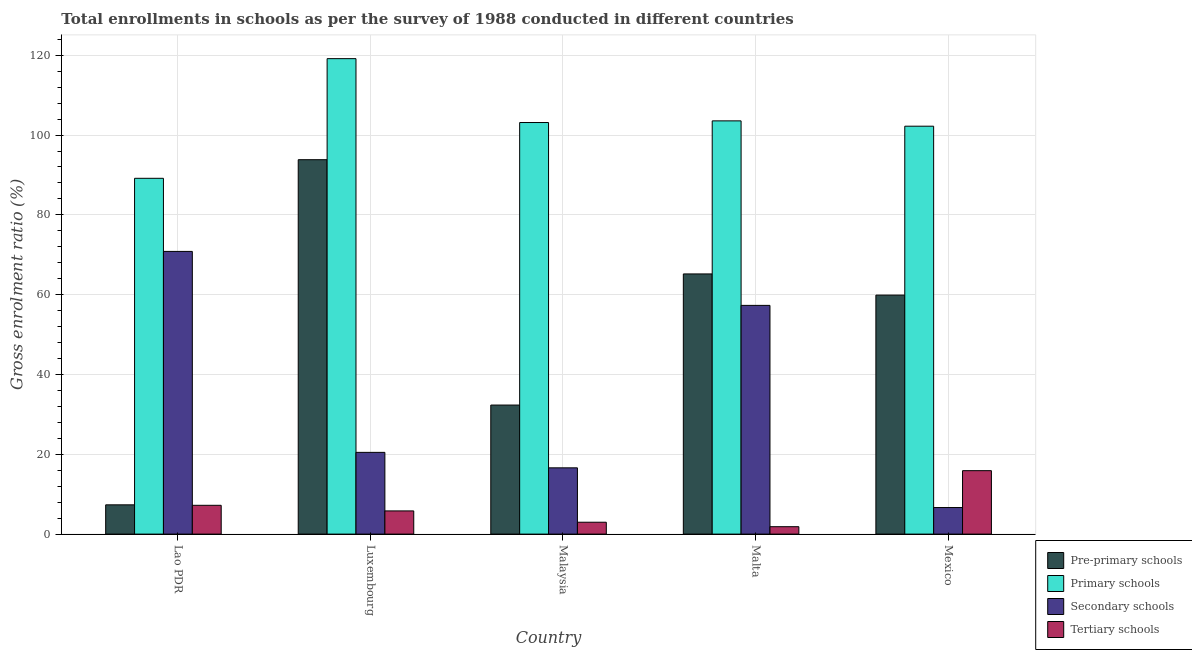How many groups of bars are there?
Provide a succinct answer. 5. What is the label of the 1st group of bars from the left?
Your response must be concise. Lao PDR. In how many cases, is the number of bars for a given country not equal to the number of legend labels?
Offer a very short reply. 0. What is the gross enrolment ratio in tertiary schools in Malta?
Offer a terse response. 1.86. Across all countries, what is the maximum gross enrolment ratio in tertiary schools?
Provide a succinct answer. 15.9. Across all countries, what is the minimum gross enrolment ratio in primary schools?
Ensure brevity in your answer.  89.17. In which country was the gross enrolment ratio in secondary schools maximum?
Your answer should be compact. Lao PDR. In which country was the gross enrolment ratio in primary schools minimum?
Keep it short and to the point. Lao PDR. What is the total gross enrolment ratio in pre-primary schools in the graph?
Keep it short and to the point. 258.6. What is the difference between the gross enrolment ratio in pre-primary schools in Luxembourg and that in Malta?
Give a very brief answer. 28.63. What is the difference between the gross enrolment ratio in secondary schools in Malaysia and the gross enrolment ratio in primary schools in Luxembourg?
Make the answer very short. -102.55. What is the average gross enrolment ratio in pre-primary schools per country?
Ensure brevity in your answer.  51.72. What is the difference between the gross enrolment ratio in tertiary schools and gross enrolment ratio in pre-primary schools in Lao PDR?
Give a very brief answer. -0.12. What is the ratio of the gross enrolment ratio in tertiary schools in Lao PDR to that in Malaysia?
Your answer should be compact. 2.42. Is the difference between the gross enrolment ratio in pre-primary schools in Luxembourg and Malta greater than the difference between the gross enrolment ratio in tertiary schools in Luxembourg and Malta?
Keep it short and to the point. Yes. What is the difference between the highest and the second highest gross enrolment ratio in pre-primary schools?
Offer a terse response. 28.63. What is the difference between the highest and the lowest gross enrolment ratio in pre-primary schools?
Provide a succinct answer. 86.49. In how many countries, is the gross enrolment ratio in secondary schools greater than the average gross enrolment ratio in secondary schools taken over all countries?
Ensure brevity in your answer.  2. What does the 2nd bar from the left in Mexico represents?
Your answer should be compact. Primary schools. What does the 1st bar from the right in Malaysia represents?
Provide a succinct answer. Tertiary schools. Is it the case that in every country, the sum of the gross enrolment ratio in pre-primary schools and gross enrolment ratio in primary schools is greater than the gross enrolment ratio in secondary schools?
Keep it short and to the point. Yes. Are the values on the major ticks of Y-axis written in scientific E-notation?
Your answer should be compact. No. Does the graph contain grids?
Provide a succinct answer. Yes. How many legend labels are there?
Offer a very short reply. 4. What is the title of the graph?
Provide a succinct answer. Total enrollments in schools as per the survey of 1988 conducted in different countries. What is the label or title of the X-axis?
Make the answer very short. Country. What is the label or title of the Y-axis?
Provide a short and direct response. Gross enrolment ratio (%). What is the Gross enrolment ratio (%) of Pre-primary schools in Lao PDR?
Ensure brevity in your answer.  7.33. What is the Gross enrolment ratio (%) in Primary schools in Lao PDR?
Your answer should be compact. 89.17. What is the Gross enrolment ratio (%) in Secondary schools in Lao PDR?
Provide a succinct answer. 70.84. What is the Gross enrolment ratio (%) in Tertiary schools in Lao PDR?
Your answer should be very brief. 7.22. What is the Gross enrolment ratio (%) of Pre-primary schools in Luxembourg?
Offer a terse response. 93.83. What is the Gross enrolment ratio (%) in Primary schools in Luxembourg?
Your answer should be compact. 119.15. What is the Gross enrolment ratio (%) in Secondary schools in Luxembourg?
Your answer should be compact. 20.48. What is the Gross enrolment ratio (%) of Tertiary schools in Luxembourg?
Provide a succinct answer. 5.81. What is the Gross enrolment ratio (%) of Pre-primary schools in Malaysia?
Your answer should be very brief. 32.34. What is the Gross enrolment ratio (%) of Primary schools in Malaysia?
Offer a very short reply. 103.14. What is the Gross enrolment ratio (%) in Secondary schools in Malaysia?
Ensure brevity in your answer.  16.61. What is the Gross enrolment ratio (%) of Tertiary schools in Malaysia?
Your answer should be compact. 2.98. What is the Gross enrolment ratio (%) of Pre-primary schools in Malta?
Your answer should be very brief. 65.2. What is the Gross enrolment ratio (%) of Primary schools in Malta?
Make the answer very short. 103.56. What is the Gross enrolment ratio (%) in Secondary schools in Malta?
Give a very brief answer. 57.32. What is the Gross enrolment ratio (%) of Tertiary schools in Malta?
Offer a terse response. 1.86. What is the Gross enrolment ratio (%) of Pre-primary schools in Mexico?
Your answer should be compact. 59.89. What is the Gross enrolment ratio (%) in Primary schools in Mexico?
Keep it short and to the point. 102.22. What is the Gross enrolment ratio (%) in Secondary schools in Mexico?
Provide a short and direct response. 6.66. What is the Gross enrolment ratio (%) of Tertiary schools in Mexico?
Keep it short and to the point. 15.9. Across all countries, what is the maximum Gross enrolment ratio (%) in Pre-primary schools?
Your answer should be very brief. 93.83. Across all countries, what is the maximum Gross enrolment ratio (%) of Primary schools?
Offer a very short reply. 119.15. Across all countries, what is the maximum Gross enrolment ratio (%) of Secondary schools?
Your answer should be very brief. 70.84. Across all countries, what is the maximum Gross enrolment ratio (%) in Tertiary schools?
Your answer should be very brief. 15.9. Across all countries, what is the minimum Gross enrolment ratio (%) of Pre-primary schools?
Your answer should be compact. 7.33. Across all countries, what is the minimum Gross enrolment ratio (%) of Primary schools?
Make the answer very short. 89.17. Across all countries, what is the minimum Gross enrolment ratio (%) of Secondary schools?
Provide a short and direct response. 6.66. Across all countries, what is the minimum Gross enrolment ratio (%) of Tertiary schools?
Keep it short and to the point. 1.86. What is the total Gross enrolment ratio (%) in Pre-primary schools in the graph?
Your answer should be compact. 258.6. What is the total Gross enrolment ratio (%) in Primary schools in the graph?
Your response must be concise. 517.24. What is the total Gross enrolment ratio (%) in Secondary schools in the graph?
Offer a very short reply. 171.91. What is the total Gross enrolment ratio (%) in Tertiary schools in the graph?
Provide a short and direct response. 33.76. What is the difference between the Gross enrolment ratio (%) of Pre-primary schools in Lao PDR and that in Luxembourg?
Ensure brevity in your answer.  -86.49. What is the difference between the Gross enrolment ratio (%) in Primary schools in Lao PDR and that in Luxembourg?
Keep it short and to the point. -29.99. What is the difference between the Gross enrolment ratio (%) of Secondary schools in Lao PDR and that in Luxembourg?
Offer a very short reply. 50.36. What is the difference between the Gross enrolment ratio (%) in Tertiary schools in Lao PDR and that in Luxembourg?
Offer a very short reply. 1.4. What is the difference between the Gross enrolment ratio (%) in Pre-primary schools in Lao PDR and that in Malaysia?
Make the answer very short. -25. What is the difference between the Gross enrolment ratio (%) of Primary schools in Lao PDR and that in Malaysia?
Your answer should be compact. -13.98. What is the difference between the Gross enrolment ratio (%) in Secondary schools in Lao PDR and that in Malaysia?
Offer a terse response. 54.24. What is the difference between the Gross enrolment ratio (%) in Tertiary schools in Lao PDR and that in Malaysia?
Give a very brief answer. 4.24. What is the difference between the Gross enrolment ratio (%) of Pre-primary schools in Lao PDR and that in Malta?
Ensure brevity in your answer.  -57.86. What is the difference between the Gross enrolment ratio (%) in Primary schools in Lao PDR and that in Malta?
Give a very brief answer. -14.39. What is the difference between the Gross enrolment ratio (%) in Secondary schools in Lao PDR and that in Malta?
Ensure brevity in your answer.  13.52. What is the difference between the Gross enrolment ratio (%) in Tertiary schools in Lao PDR and that in Malta?
Your response must be concise. 5.36. What is the difference between the Gross enrolment ratio (%) of Pre-primary schools in Lao PDR and that in Mexico?
Make the answer very short. -52.56. What is the difference between the Gross enrolment ratio (%) of Primary schools in Lao PDR and that in Mexico?
Your answer should be very brief. -13.06. What is the difference between the Gross enrolment ratio (%) of Secondary schools in Lao PDR and that in Mexico?
Offer a very short reply. 64.19. What is the difference between the Gross enrolment ratio (%) in Tertiary schools in Lao PDR and that in Mexico?
Provide a succinct answer. -8.68. What is the difference between the Gross enrolment ratio (%) of Pre-primary schools in Luxembourg and that in Malaysia?
Your answer should be very brief. 61.49. What is the difference between the Gross enrolment ratio (%) in Primary schools in Luxembourg and that in Malaysia?
Your response must be concise. 16.01. What is the difference between the Gross enrolment ratio (%) of Secondary schools in Luxembourg and that in Malaysia?
Provide a succinct answer. 3.88. What is the difference between the Gross enrolment ratio (%) of Tertiary schools in Luxembourg and that in Malaysia?
Your answer should be compact. 2.84. What is the difference between the Gross enrolment ratio (%) of Pre-primary schools in Luxembourg and that in Malta?
Provide a succinct answer. 28.63. What is the difference between the Gross enrolment ratio (%) of Primary schools in Luxembourg and that in Malta?
Your answer should be compact. 15.59. What is the difference between the Gross enrolment ratio (%) of Secondary schools in Luxembourg and that in Malta?
Your response must be concise. -36.83. What is the difference between the Gross enrolment ratio (%) of Tertiary schools in Luxembourg and that in Malta?
Provide a succinct answer. 3.96. What is the difference between the Gross enrolment ratio (%) in Pre-primary schools in Luxembourg and that in Mexico?
Make the answer very short. 33.94. What is the difference between the Gross enrolment ratio (%) of Primary schools in Luxembourg and that in Mexico?
Provide a succinct answer. 16.93. What is the difference between the Gross enrolment ratio (%) of Secondary schools in Luxembourg and that in Mexico?
Give a very brief answer. 13.83. What is the difference between the Gross enrolment ratio (%) of Tertiary schools in Luxembourg and that in Mexico?
Offer a very short reply. -10.09. What is the difference between the Gross enrolment ratio (%) of Pre-primary schools in Malaysia and that in Malta?
Give a very brief answer. -32.86. What is the difference between the Gross enrolment ratio (%) of Primary schools in Malaysia and that in Malta?
Your response must be concise. -0.41. What is the difference between the Gross enrolment ratio (%) in Secondary schools in Malaysia and that in Malta?
Ensure brevity in your answer.  -40.71. What is the difference between the Gross enrolment ratio (%) of Tertiary schools in Malaysia and that in Malta?
Provide a short and direct response. 1.12. What is the difference between the Gross enrolment ratio (%) of Pre-primary schools in Malaysia and that in Mexico?
Offer a terse response. -27.56. What is the difference between the Gross enrolment ratio (%) in Primary schools in Malaysia and that in Mexico?
Your answer should be compact. 0.92. What is the difference between the Gross enrolment ratio (%) of Secondary schools in Malaysia and that in Mexico?
Offer a terse response. 9.95. What is the difference between the Gross enrolment ratio (%) in Tertiary schools in Malaysia and that in Mexico?
Provide a short and direct response. -12.92. What is the difference between the Gross enrolment ratio (%) in Pre-primary schools in Malta and that in Mexico?
Offer a very short reply. 5.31. What is the difference between the Gross enrolment ratio (%) in Primary schools in Malta and that in Mexico?
Offer a very short reply. 1.33. What is the difference between the Gross enrolment ratio (%) in Secondary schools in Malta and that in Mexico?
Your answer should be compact. 50.66. What is the difference between the Gross enrolment ratio (%) of Tertiary schools in Malta and that in Mexico?
Your answer should be very brief. -14.04. What is the difference between the Gross enrolment ratio (%) of Pre-primary schools in Lao PDR and the Gross enrolment ratio (%) of Primary schools in Luxembourg?
Make the answer very short. -111.82. What is the difference between the Gross enrolment ratio (%) in Pre-primary schools in Lao PDR and the Gross enrolment ratio (%) in Secondary schools in Luxembourg?
Provide a short and direct response. -13.15. What is the difference between the Gross enrolment ratio (%) of Pre-primary schools in Lao PDR and the Gross enrolment ratio (%) of Tertiary schools in Luxembourg?
Make the answer very short. 1.52. What is the difference between the Gross enrolment ratio (%) in Primary schools in Lao PDR and the Gross enrolment ratio (%) in Secondary schools in Luxembourg?
Provide a short and direct response. 68.68. What is the difference between the Gross enrolment ratio (%) in Primary schools in Lao PDR and the Gross enrolment ratio (%) in Tertiary schools in Luxembourg?
Your response must be concise. 83.35. What is the difference between the Gross enrolment ratio (%) of Secondary schools in Lao PDR and the Gross enrolment ratio (%) of Tertiary schools in Luxembourg?
Give a very brief answer. 65.03. What is the difference between the Gross enrolment ratio (%) of Pre-primary schools in Lao PDR and the Gross enrolment ratio (%) of Primary schools in Malaysia?
Ensure brevity in your answer.  -95.81. What is the difference between the Gross enrolment ratio (%) in Pre-primary schools in Lao PDR and the Gross enrolment ratio (%) in Secondary schools in Malaysia?
Provide a short and direct response. -9.27. What is the difference between the Gross enrolment ratio (%) in Pre-primary schools in Lao PDR and the Gross enrolment ratio (%) in Tertiary schools in Malaysia?
Ensure brevity in your answer.  4.36. What is the difference between the Gross enrolment ratio (%) of Primary schools in Lao PDR and the Gross enrolment ratio (%) of Secondary schools in Malaysia?
Your answer should be compact. 72.56. What is the difference between the Gross enrolment ratio (%) of Primary schools in Lao PDR and the Gross enrolment ratio (%) of Tertiary schools in Malaysia?
Offer a terse response. 86.19. What is the difference between the Gross enrolment ratio (%) in Secondary schools in Lao PDR and the Gross enrolment ratio (%) in Tertiary schools in Malaysia?
Your response must be concise. 67.87. What is the difference between the Gross enrolment ratio (%) of Pre-primary schools in Lao PDR and the Gross enrolment ratio (%) of Primary schools in Malta?
Offer a terse response. -96.22. What is the difference between the Gross enrolment ratio (%) of Pre-primary schools in Lao PDR and the Gross enrolment ratio (%) of Secondary schools in Malta?
Offer a terse response. -49.98. What is the difference between the Gross enrolment ratio (%) of Pre-primary schools in Lao PDR and the Gross enrolment ratio (%) of Tertiary schools in Malta?
Your response must be concise. 5.48. What is the difference between the Gross enrolment ratio (%) of Primary schools in Lao PDR and the Gross enrolment ratio (%) of Secondary schools in Malta?
Provide a short and direct response. 31.85. What is the difference between the Gross enrolment ratio (%) in Primary schools in Lao PDR and the Gross enrolment ratio (%) in Tertiary schools in Malta?
Provide a succinct answer. 87.31. What is the difference between the Gross enrolment ratio (%) in Secondary schools in Lao PDR and the Gross enrolment ratio (%) in Tertiary schools in Malta?
Offer a terse response. 68.99. What is the difference between the Gross enrolment ratio (%) in Pre-primary schools in Lao PDR and the Gross enrolment ratio (%) in Primary schools in Mexico?
Provide a short and direct response. -94.89. What is the difference between the Gross enrolment ratio (%) in Pre-primary schools in Lao PDR and the Gross enrolment ratio (%) in Secondary schools in Mexico?
Keep it short and to the point. 0.68. What is the difference between the Gross enrolment ratio (%) of Pre-primary schools in Lao PDR and the Gross enrolment ratio (%) of Tertiary schools in Mexico?
Offer a very short reply. -8.56. What is the difference between the Gross enrolment ratio (%) of Primary schools in Lao PDR and the Gross enrolment ratio (%) of Secondary schools in Mexico?
Make the answer very short. 82.51. What is the difference between the Gross enrolment ratio (%) of Primary schools in Lao PDR and the Gross enrolment ratio (%) of Tertiary schools in Mexico?
Give a very brief answer. 73.27. What is the difference between the Gross enrolment ratio (%) of Secondary schools in Lao PDR and the Gross enrolment ratio (%) of Tertiary schools in Mexico?
Ensure brevity in your answer.  54.94. What is the difference between the Gross enrolment ratio (%) of Pre-primary schools in Luxembourg and the Gross enrolment ratio (%) of Primary schools in Malaysia?
Offer a very short reply. -9.31. What is the difference between the Gross enrolment ratio (%) of Pre-primary schools in Luxembourg and the Gross enrolment ratio (%) of Secondary schools in Malaysia?
Make the answer very short. 77.22. What is the difference between the Gross enrolment ratio (%) in Pre-primary schools in Luxembourg and the Gross enrolment ratio (%) in Tertiary schools in Malaysia?
Your response must be concise. 90.85. What is the difference between the Gross enrolment ratio (%) in Primary schools in Luxembourg and the Gross enrolment ratio (%) in Secondary schools in Malaysia?
Provide a short and direct response. 102.55. What is the difference between the Gross enrolment ratio (%) of Primary schools in Luxembourg and the Gross enrolment ratio (%) of Tertiary schools in Malaysia?
Offer a very short reply. 116.18. What is the difference between the Gross enrolment ratio (%) in Secondary schools in Luxembourg and the Gross enrolment ratio (%) in Tertiary schools in Malaysia?
Your answer should be very brief. 17.51. What is the difference between the Gross enrolment ratio (%) of Pre-primary schools in Luxembourg and the Gross enrolment ratio (%) of Primary schools in Malta?
Keep it short and to the point. -9.73. What is the difference between the Gross enrolment ratio (%) in Pre-primary schools in Luxembourg and the Gross enrolment ratio (%) in Secondary schools in Malta?
Provide a short and direct response. 36.51. What is the difference between the Gross enrolment ratio (%) of Pre-primary schools in Luxembourg and the Gross enrolment ratio (%) of Tertiary schools in Malta?
Your answer should be compact. 91.97. What is the difference between the Gross enrolment ratio (%) in Primary schools in Luxembourg and the Gross enrolment ratio (%) in Secondary schools in Malta?
Give a very brief answer. 61.83. What is the difference between the Gross enrolment ratio (%) of Primary schools in Luxembourg and the Gross enrolment ratio (%) of Tertiary schools in Malta?
Keep it short and to the point. 117.3. What is the difference between the Gross enrolment ratio (%) in Secondary schools in Luxembourg and the Gross enrolment ratio (%) in Tertiary schools in Malta?
Ensure brevity in your answer.  18.63. What is the difference between the Gross enrolment ratio (%) of Pre-primary schools in Luxembourg and the Gross enrolment ratio (%) of Primary schools in Mexico?
Offer a very short reply. -8.39. What is the difference between the Gross enrolment ratio (%) in Pre-primary schools in Luxembourg and the Gross enrolment ratio (%) in Secondary schools in Mexico?
Your response must be concise. 87.17. What is the difference between the Gross enrolment ratio (%) in Pre-primary schools in Luxembourg and the Gross enrolment ratio (%) in Tertiary schools in Mexico?
Give a very brief answer. 77.93. What is the difference between the Gross enrolment ratio (%) of Primary schools in Luxembourg and the Gross enrolment ratio (%) of Secondary schools in Mexico?
Give a very brief answer. 112.5. What is the difference between the Gross enrolment ratio (%) of Primary schools in Luxembourg and the Gross enrolment ratio (%) of Tertiary schools in Mexico?
Give a very brief answer. 103.25. What is the difference between the Gross enrolment ratio (%) in Secondary schools in Luxembourg and the Gross enrolment ratio (%) in Tertiary schools in Mexico?
Your response must be concise. 4.59. What is the difference between the Gross enrolment ratio (%) in Pre-primary schools in Malaysia and the Gross enrolment ratio (%) in Primary schools in Malta?
Give a very brief answer. -71.22. What is the difference between the Gross enrolment ratio (%) of Pre-primary schools in Malaysia and the Gross enrolment ratio (%) of Secondary schools in Malta?
Offer a very short reply. -24.98. What is the difference between the Gross enrolment ratio (%) of Pre-primary schools in Malaysia and the Gross enrolment ratio (%) of Tertiary schools in Malta?
Your response must be concise. 30.48. What is the difference between the Gross enrolment ratio (%) of Primary schools in Malaysia and the Gross enrolment ratio (%) of Secondary schools in Malta?
Keep it short and to the point. 45.82. What is the difference between the Gross enrolment ratio (%) in Primary schools in Malaysia and the Gross enrolment ratio (%) in Tertiary schools in Malta?
Give a very brief answer. 101.29. What is the difference between the Gross enrolment ratio (%) in Secondary schools in Malaysia and the Gross enrolment ratio (%) in Tertiary schools in Malta?
Your answer should be very brief. 14.75. What is the difference between the Gross enrolment ratio (%) in Pre-primary schools in Malaysia and the Gross enrolment ratio (%) in Primary schools in Mexico?
Offer a very short reply. -69.88. What is the difference between the Gross enrolment ratio (%) in Pre-primary schools in Malaysia and the Gross enrolment ratio (%) in Secondary schools in Mexico?
Give a very brief answer. 25.68. What is the difference between the Gross enrolment ratio (%) in Pre-primary schools in Malaysia and the Gross enrolment ratio (%) in Tertiary schools in Mexico?
Keep it short and to the point. 16.44. What is the difference between the Gross enrolment ratio (%) of Primary schools in Malaysia and the Gross enrolment ratio (%) of Secondary schools in Mexico?
Offer a terse response. 96.49. What is the difference between the Gross enrolment ratio (%) in Primary schools in Malaysia and the Gross enrolment ratio (%) in Tertiary schools in Mexico?
Offer a terse response. 87.25. What is the difference between the Gross enrolment ratio (%) in Secondary schools in Malaysia and the Gross enrolment ratio (%) in Tertiary schools in Mexico?
Your answer should be compact. 0.71. What is the difference between the Gross enrolment ratio (%) of Pre-primary schools in Malta and the Gross enrolment ratio (%) of Primary schools in Mexico?
Offer a terse response. -37.02. What is the difference between the Gross enrolment ratio (%) in Pre-primary schools in Malta and the Gross enrolment ratio (%) in Secondary schools in Mexico?
Make the answer very short. 58.54. What is the difference between the Gross enrolment ratio (%) in Pre-primary schools in Malta and the Gross enrolment ratio (%) in Tertiary schools in Mexico?
Offer a very short reply. 49.3. What is the difference between the Gross enrolment ratio (%) of Primary schools in Malta and the Gross enrolment ratio (%) of Secondary schools in Mexico?
Give a very brief answer. 96.9. What is the difference between the Gross enrolment ratio (%) of Primary schools in Malta and the Gross enrolment ratio (%) of Tertiary schools in Mexico?
Provide a succinct answer. 87.66. What is the difference between the Gross enrolment ratio (%) in Secondary schools in Malta and the Gross enrolment ratio (%) in Tertiary schools in Mexico?
Ensure brevity in your answer.  41.42. What is the average Gross enrolment ratio (%) in Pre-primary schools per country?
Provide a short and direct response. 51.72. What is the average Gross enrolment ratio (%) in Primary schools per country?
Your answer should be compact. 103.45. What is the average Gross enrolment ratio (%) of Secondary schools per country?
Make the answer very short. 34.38. What is the average Gross enrolment ratio (%) of Tertiary schools per country?
Keep it short and to the point. 6.75. What is the difference between the Gross enrolment ratio (%) in Pre-primary schools and Gross enrolment ratio (%) in Primary schools in Lao PDR?
Keep it short and to the point. -81.83. What is the difference between the Gross enrolment ratio (%) of Pre-primary schools and Gross enrolment ratio (%) of Secondary schools in Lao PDR?
Provide a short and direct response. -63.51. What is the difference between the Gross enrolment ratio (%) of Pre-primary schools and Gross enrolment ratio (%) of Tertiary schools in Lao PDR?
Offer a terse response. 0.12. What is the difference between the Gross enrolment ratio (%) of Primary schools and Gross enrolment ratio (%) of Secondary schools in Lao PDR?
Offer a very short reply. 18.32. What is the difference between the Gross enrolment ratio (%) of Primary schools and Gross enrolment ratio (%) of Tertiary schools in Lao PDR?
Your response must be concise. 81.95. What is the difference between the Gross enrolment ratio (%) of Secondary schools and Gross enrolment ratio (%) of Tertiary schools in Lao PDR?
Your response must be concise. 63.63. What is the difference between the Gross enrolment ratio (%) in Pre-primary schools and Gross enrolment ratio (%) in Primary schools in Luxembourg?
Keep it short and to the point. -25.32. What is the difference between the Gross enrolment ratio (%) of Pre-primary schools and Gross enrolment ratio (%) of Secondary schools in Luxembourg?
Give a very brief answer. 73.34. What is the difference between the Gross enrolment ratio (%) of Pre-primary schools and Gross enrolment ratio (%) of Tertiary schools in Luxembourg?
Your response must be concise. 88.02. What is the difference between the Gross enrolment ratio (%) of Primary schools and Gross enrolment ratio (%) of Secondary schools in Luxembourg?
Your answer should be very brief. 98.67. What is the difference between the Gross enrolment ratio (%) in Primary schools and Gross enrolment ratio (%) in Tertiary schools in Luxembourg?
Provide a short and direct response. 113.34. What is the difference between the Gross enrolment ratio (%) of Secondary schools and Gross enrolment ratio (%) of Tertiary schools in Luxembourg?
Your answer should be compact. 14.67. What is the difference between the Gross enrolment ratio (%) in Pre-primary schools and Gross enrolment ratio (%) in Primary schools in Malaysia?
Your response must be concise. -70.8. What is the difference between the Gross enrolment ratio (%) of Pre-primary schools and Gross enrolment ratio (%) of Secondary schools in Malaysia?
Your response must be concise. 15.73. What is the difference between the Gross enrolment ratio (%) in Pre-primary schools and Gross enrolment ratio (%) in Tertiary schools in Malaysia?
Offer a terse response. 29.36. What is the difference between the Gross enrolment ratio (%) of Primary schools and Gross enrolment ratio (%) of Secondary schools in Malaysia?
Give a very brief answer. 86.54. What is the difference between the Gross enrolment ratio (%) of Primary schools and Gross enrolment ratio (%) of Tertiary schools in Malaysia?
Your answer should be very brief. 100.17. What is the difference between the Gross enrolment ratio (%) in Secondary schools and Gross enrolment ratio (%) in Tertiary schools in Malaysia?
Provide a short and direct response. 13.63. What is the difference between the Gross enrolment ratio (%) of Pre-primary schools and Gross enrolment ratio (%) of Primary schools in Malta?
Offer a very short reply. -38.36. What is the difference between the Gross enrolment ratio (%) in Pre-primary schools and Gross enrolment ratio (%) in Secondary schools in Malta?
Offer a very short reply. 7.88. What is the difference between the Gross enrolment ratio (%) of Pre-primary schools and Gross enrolment ratio (%) of Tertiary schools in Malta?
Ensure brevity in your answer.  63.34. What is the difference between the Gross enrolment ratio (%) in Primary schools and Gross enrolment ratio (%) in Secondary schools in Malta?
Offer a very short reply. 46.24. What is the difference between the Gross enrolment ratio (%) of Primary schools and Gross enrolment ratio (%) of Tertiary schools in Malta?
Offer a terse response. 101.7. What is the difference between the Gross enrolment ratio (%) in Secondary schools and Gross enrolment ratio (%) in Tertiary schools in Malta?
Provide a short and direct response. 55.46. What is the difference between the Gross enrolment ratio (%) of Pre-primary schools and Gross enrolment ratio (%) of Primary schools in Mexico?
Provide a succinct answer. -42.33. What is the difference between the Gross enrolment ratio (%) in Pre-primary schools and Gross enrolment ratio (%) in Secondary schools in Mexico?
Offer a very short reply. 53.24. What is the difference between the Gross enrolment ratio (%) of Pre-primary schools and Gross enrolment ratio (%) of Tertiary schools in Mexico?
Provide a succinct answer. 44. What is the difference between the Gross enrolment ratio (%) in Primary schools and Gross enrolment ratio (%) in Secondary schools in Mexico?
Provide a short and direct response. 95.57. What is the difference between the Gross enrolment ratio (%) in Primary schools and Gross enrolment ratio (%) in Tertiary schools in Mexico?
Your answer should be very brief. 86.32. What is the difference between the Gross enrolment ratio (%) in Secondary schools and Gross enrolment ratio (%) in Tertiary schools in Mexico?
Your answer should be compact. -9.24. What is the ratio of the Gross enrolment ratio (%) in Pre-primary schools in Lao PDR to that in Luxembourg?
Make the answer very short. 0.08. What is the ratio of the Gross enrolment ratio (%) in Primary schools in Lao PDR to that in Luxembourg?
Your answer should be very brief. 0.75. What is the ratio of the Gross enrolment ratio (%) of Secondary schools in Lao PDR to that in Luxembourg?
Give a very brief answer. 3.46. What is the ratio of the Gross enrolment ratio (%) of Tertiary schools in Lao PDR to that in Luxembourg?
Keep it short and to the point. 1.24. What is the ratio of the Gross enrolment ratio (%) in Pre-primary schools in Lao PDR to that in Malaysia?
Ensure brevity in your answer.  0.23. What is the ratio of the Gross enrolment ratio (%) in Primary schools in Lao PDR to that in Malaysia?
Your answer should be compact. 0.86. What is the ratio of the Gross enrolment ratio (%) in Secondary schools in Lao PDR to that in Malaysia?
Your response must be concise. 4.27. What is the ratio of the Gross enrolment ratio (%) of Tertiary schools in Lao PDR to that in Malaysia?
Your answer should be compact. 2.42. What is the ratio of the Gross enrolment ratio (%) in Pre-primary schools in Lao PDR to that in Malta?
Keep it short and to the point. 0.11. What is the ratio of the Gross enrolment ratio (%) of Primary schools in Lao PDR to that in Malta?
Keep it short and to the point. 0.86. What is the ratio of the Gross enrolment ratio (%) of Secondary schools in Lao PDR to that in Malta?
Your answer should be compact. 1.24. What is the ratio of the Gross enrolment ratio (%) of Tertiary schools in Lao PDR to that in Malta?
Provide a short and direct response. 3.89. What is the ratio of the Gross enrolment ratio (%) of Pre-primary schools in Lao PDR to that in Mexico?
Ensure brevity in your answer.  0.12. What is the ratio of the Gross enrolment ratio (%) in Primary schools in Lao PDR to that in Mexico?
Provide a short and direct response. 0.87. What is the ratio of the Gross enrolment ratio (%) of Secondary schools in Lao PDR to that in Mexico?
Provide a short and direct response. 10.64. What is the ratio of the Gross enrolment ratio (%) of Tertiary schools in Lao PDR to that in Mexico?
Your answer should be compact. 0.45. What is the ratio of the Gross enrolment ratio (%) in Pre-primary schools in Luxembourg to that in Malaysia?
Keep it short and to the point. 2.9. What is the ratio of the Gross enrolment ratio (%) in Primary schools in Luxembourg to that in Malaysia?
Provide a short and direct response. 1.16. What is the ratio of the Gross enrolment ratio (%) of Secondary schools in Luxembourg to that in Malaysia?
Provide a short and direct response. 1.23. What is the ratio of the Gross enrolment ratio (%) of Tertiary schools in Luxembourg to that in Malaysia?
Ensure brevity in your answer.  1.95. What is the ratio of the Gross enrolment ratio (%) in Pre-primary schools in Luxembourg to that in Malta?
Provide a succinct answer. 1.44. What is the ratio of the Gross enrolment ratio (%) of Primary schools in Luxembourg to that in Malta?
Your answer should be very brief. 1.15. What is the ratio of the Gross enrolment ratio (%) of Secondary schools in Luxembourg to that in Malta?
Keep it short and to the point. 0.36. What is the ratio of the Gross enrolment ratio (%) of Tertiary schools in Luxembourg to that in Malta?
Give a very brief answer. 3.13. What is the ratio of the Gross enrolment ratio (%) in Pre-primary schools in Luxembourg to that in Mexico?
Ensure brevity in your answer.  1.57. What is the ratio of the Gross enrolment ratio (%) of Primary schools in Luxembourg to that in Mexico?
Your response must be concise. 1.17. What is the ratio of the Gross enrolment ratio (%) in Secondary schools in Luxembourg to that in Mexico?
Your answer should be compact. 3.08. What is the ratio of the Gross enrolment ratio (%) of Tertiary schools in Luxembourg to that in Mexico?
Your response must be concise. 0.37. What is the ratio of the Gross enrolment ratio (%) of Pre-primary schools in Malaysia to that in Malta?
Offer a terse response. 0.5. What is the ratio of the Gross enrolment ratio (%) of Secondary schools in Malaysia to that in Malta?
Ensure brevity in your answer.  0.29. What is the ratio of the Gross enrolment ratio (%) of Tertiary schools in Malaysia to that in Malta?
Ensure brevity in your answer.  1.6. What is the ratio of the Gross enrolment ratio (%) in Pre-primary schools in Malaysia to that in Mexico?
Offer a terse response. 0.54. What is the ratio of the Gross enrolment ratio (%) in Primary schools in Malaysia to that in Mexico?
Make the answer very short. 1.01. What is the ratio of the Gross enrolment ratio (%) of Secondary schools in Malaysia to that in Mexico?
Provide a succinct answer. 2.5. What is the ratio of the Gross enrolment ratio (%) in Tertiary schools in Malaysia to that in Mexico?
Your answer should be compact. 0.19. What is the ratio of the Gross enrolment ratio (%) in Pre-primary schools in Malta to that in Mexico?
Make the answer very short. 1.09. What is the ratio of the Gross enrolment ratio (%) of Primary schools in Malta to that in Mexico?
Offer a terse response. 1.01. What is the ratio of the Gross enrolment ratio (%) of Secondary schools in Malta to that in Mexico?
Give a very brief answer. 8.61. What is the ratio of the Gross enrolment ratio (%) in Tertiary schools in Malta to that in Mexico?
Provide a short and direct response. 0.12. What is the difference between the highest and the second highest Gross enrolment ratio (%) of Pre-primary schools?
Offer a terse response. 28.63. What is the difference between the highest and the second highest Gross enrolment ratio (%) of Primary schools?
Offer a terse response. 15.59. What is the difference between the highest and the second highest Gross enrolment ratio (%) of Secondary schools?
Give a very brief answer. 13.52. What is the difference between the highest and the second highest Gross enrolment ratio (%) of Tertiary schools?
Give a very brief answer. 8.68. What is the difference between the highest and the lowest Gross enrolment ratio (%) of Pre-primary schools?
Make the answer very short. 86.49. What is the difference between the highest and the lowest Gross enrolment ratio (%) of Primary schools?
Give a very brief answer. 29.99. What is the difference between the highest and the lowest Gross enrolment ratio (%) of Secondary schools?
Give a very brief answer. 64.19. What is the difference between the highest and the lowest Gross enrolment ratio (%) in Tertiary schools?
Your answer should be very brief. 14.04. 